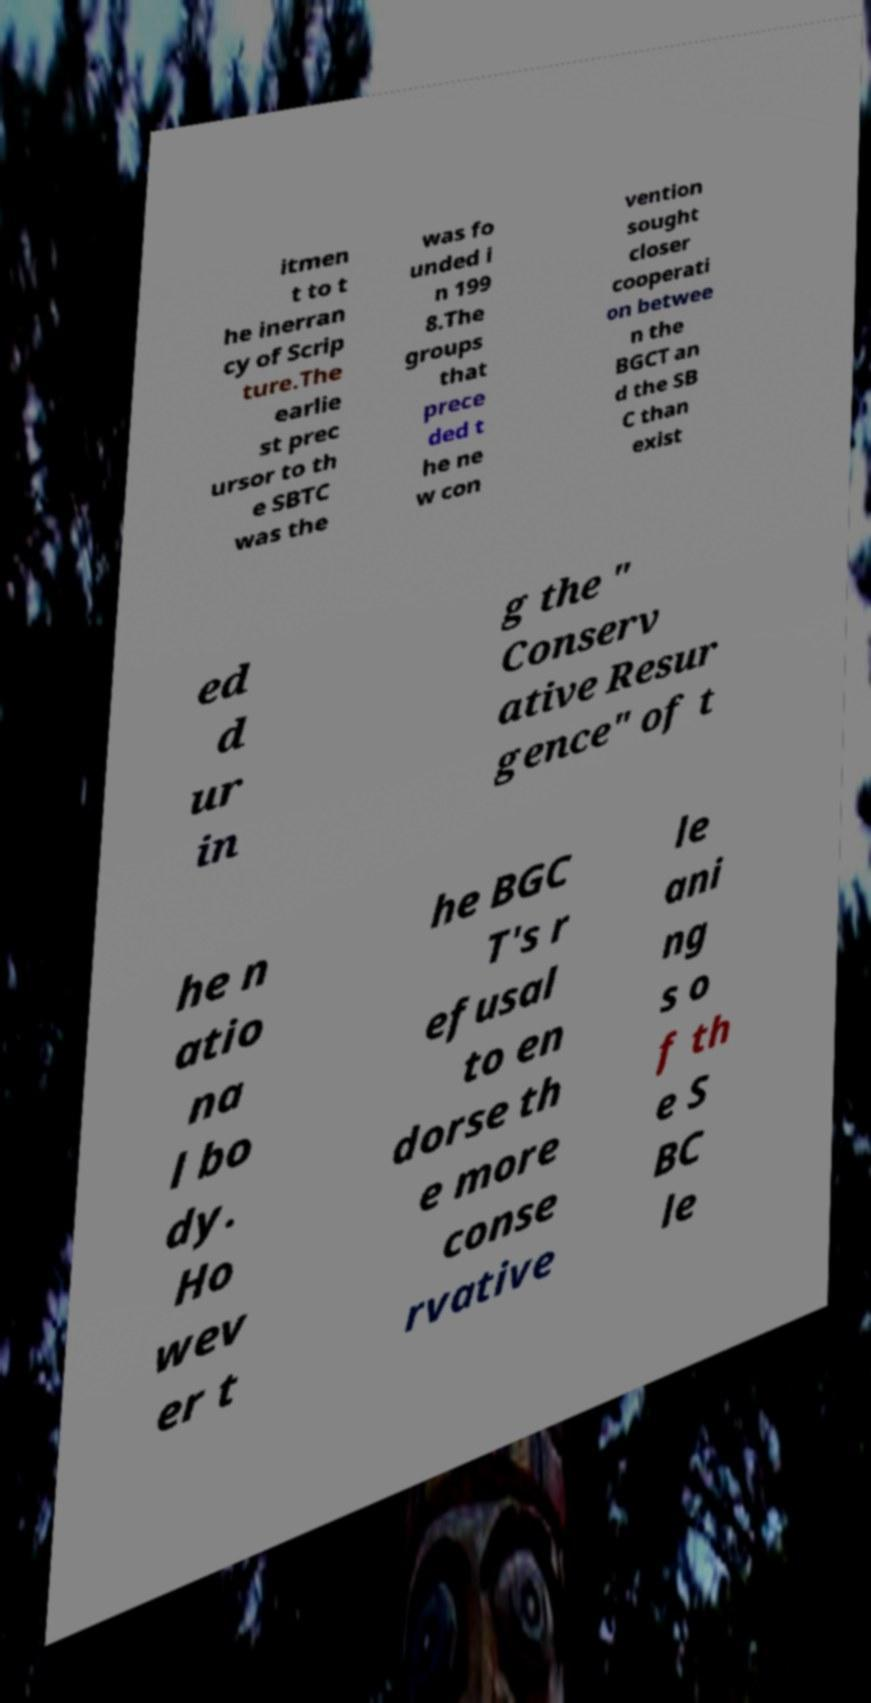What messages or text are displayed in this image? I need them in a readable, typed format. itmen t to t he inerran cy of Scrip ture.The earlie st prec ursor to th e SBTC was the was fo unded i n 199 8.The groups that prece ded t he ne w con vention sought closer cooperati on betwee n the BGCT an d the SB C than exist ed d ur in g the " Conserv ative Resur gence" of t he n atio na l bo dy. Ho wev er t he BGC T's r efusal to en dorse th e more conse rvative le ani ng s o f th e S BC le 